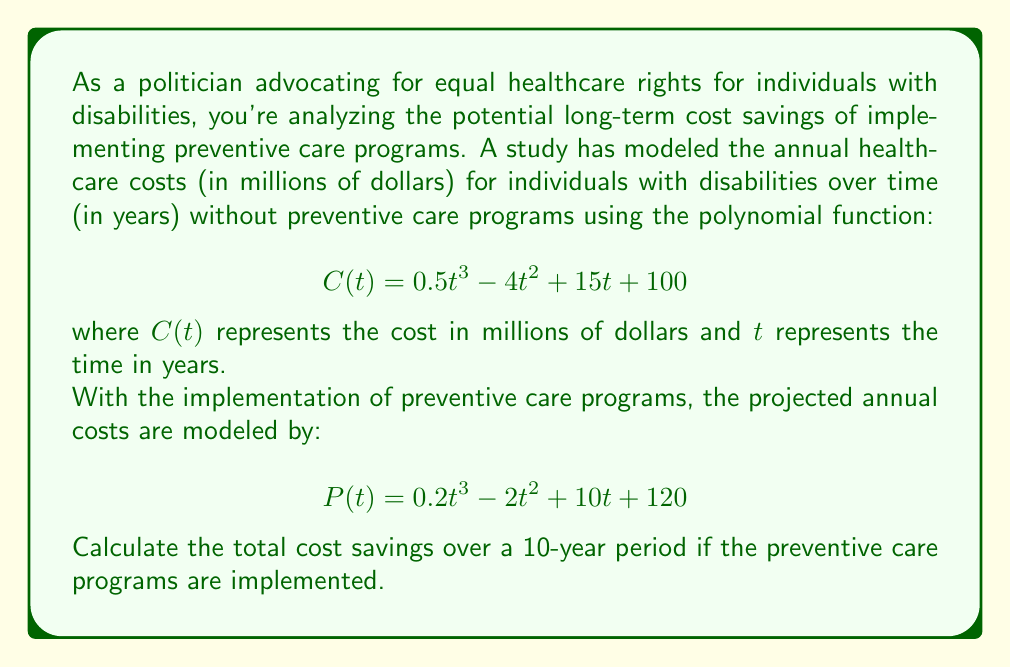Show me your answer to this math problem. To solve this problem, we need to follow these steps:

1) Calculate the total cost without preventive care programs over 10 years.
2) Calculate the total cost with preventive care programs over 10 years.
3) Find the difference between these two totals.

Step 1: Total cost without preventive care programs

We need to integrate $C(t)$ from $t=0$ to $t=10$:

$$\int_0^{10} (0.5t^3 - 4t^2 + 15t + 100) dt$$

$$= [\frac{0.5t^4}{4} - \frac{4t^3}{3} + \frac{15t^2}{2} + 100t]_0^{10}$$

$$= (\frac{0.5(10^4)}{4} - \frac{4(10^3)}{3} + \frac{15(10^2)}{2} + 100(10)) - (0)$$

$$= (1250 - 1333.33 + 750 + 1000) - 0 = 1666.67$$

The total cost without preventive care over 10 years is $1666.67 million.

Step 2: Total cost with preventive care programs

We integrate $P(t)$ from $t=0$ to $t=10$:

$$\int_0^{10} (0.2t^3 - 2t^2 + 10t + 120) dt$$

$$= [\frac{0.2t^4}{4} - \frac{2t^3}{3} + \frac{10t^2}{2} + 120t]_0^{10}$$

$$= (\frac{0.2(10^4)}{4} - \frac{2(10^3)}{3} + \frac{10(10^2)}{2} + 120(10)) - (0)$$

$$= (500 - 666.67 + 500 + 1200) - 0 = 1533.33$$

The total cost with preventive care over 10 years is $1533.33 million.

Step 3: Calculate the difference

Cost savings = Cost without preventive care - Cost with preventive care
$$1666.67 - 1533.33 = 133.34$$

Therefore, the total cost savings over a 10-year period is $133.34 million.
Answer: $133.34 million 